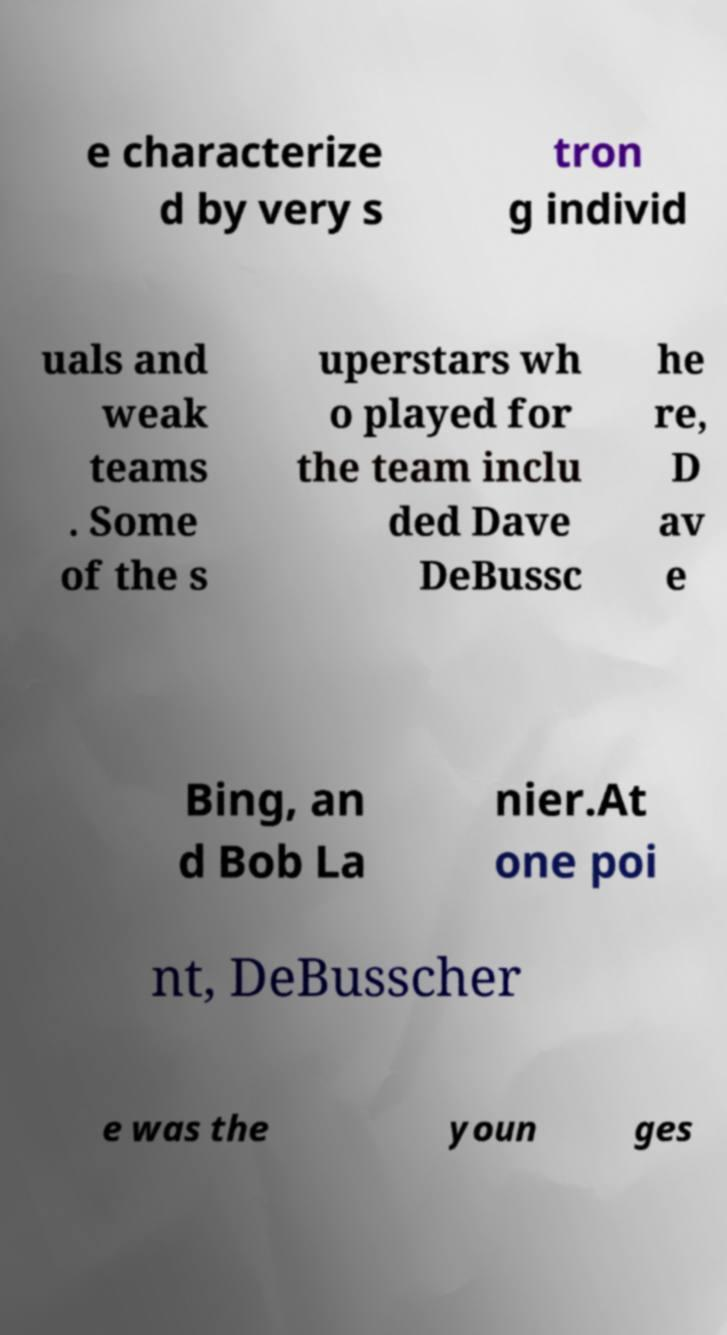Can you read and provide the text displayed in the image?This photo seems to have some interesting text. Can you extract and type it out for me? e characterize d by very s tron g individ uals and weak teams . Some of the s uperstars wh o played for the team inclu ded Dave DeBussc he re, D av e Bing, an d Bob La nier.At one poi nt, DeBusscher e was the youn ges 